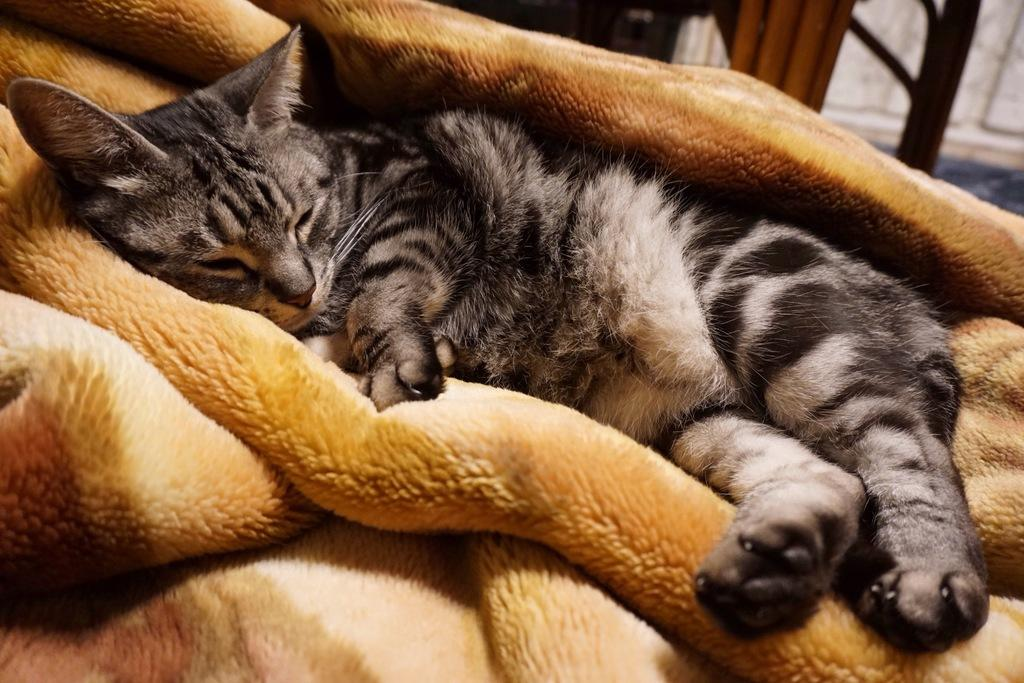What animal can be seen in the image? There is a cat in the image. What is the cat lying on? The cat is lying on a blanket. Can you describe the area in the image that appears blurred? There is a blurred area in the image where objects are present. What type of winter clothing is the cat wearing in the image? There is no winter clothing present in the image, as it features a cat lying on a blanket. 